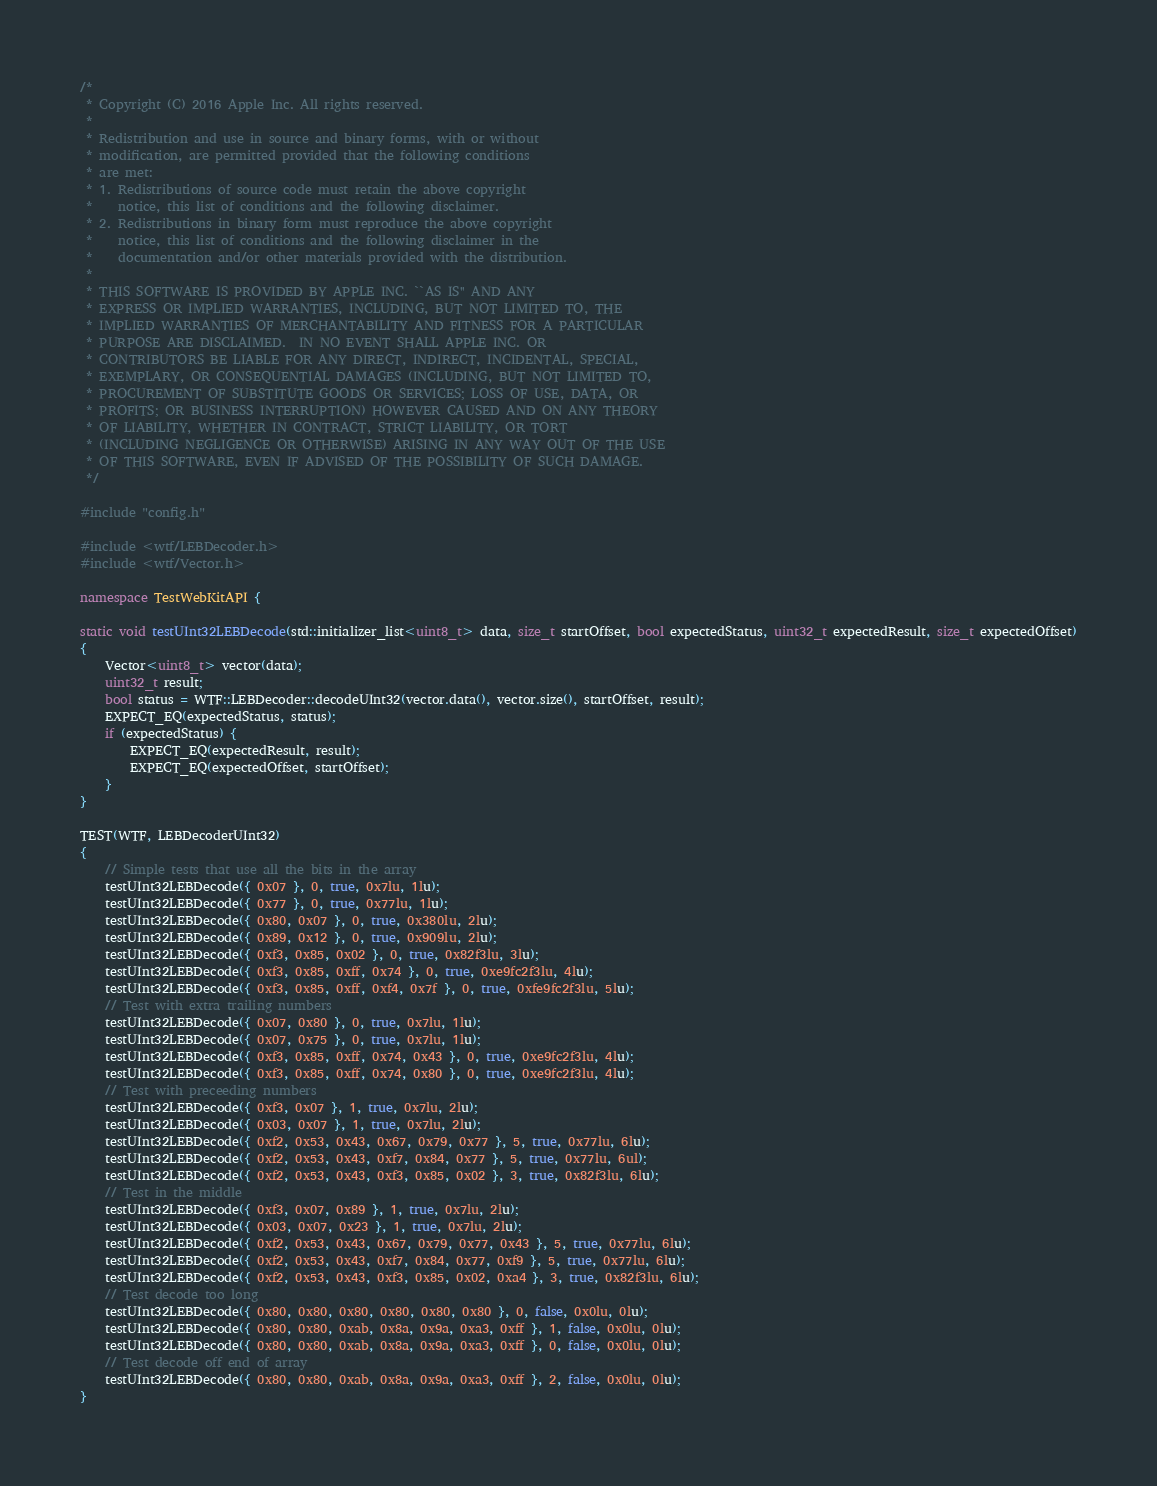Convert code to text. <code><loc_0><loc_0><loc_500><loc_500><_C++_>/*
 * Copyright (C) 2016 Apple Inc. All rights reserved.
 *
 * Redistribution and use in source and binary forms, with or without
 * modification, are permitted provided that the following conditions
 * are met:
 * 1. Redistributions of source code must retain the above copyright
 *    notice, this list of conditions and the following disclaimer.
 * 2. Redistributions in binary form must reproduce the above copyright
 *    notice, this list of conditions and the following disclaimer in the
 *    documentation and/or other materials provided with the distribution.
 *
 * THIS SOFTWARE IS PROVIDED BY APPLE INC. ``AS IS'' AND ANY
 * EXPRESS OR IMPLIED WARRANTIES, INCLUDING, BUT NOT LIMITED TO, THE
 * IMPLIED WARRANTIES OF MERCHANTABILITY AND FITNESS FOR A PARTICULAR
 * PURPOSE ARE DISCLAIMED.  IN NO EVENT SHALL APPLE INC. OR
 * CONTRIBUTORS BE LIABLE FOR ANY DIRECT, INDIRECT, INCIDENTAL, SPECIAL,
 * EXEMPLARY, OR CONSEQUENTIAL DAMAGES (INCLUDING, BUT NOT LIMITED TO,
 * PROCUREMENT OF SUBSTITUTE GOODS OR SERVICES; LOSS OF USE, DATA, OR
 * PROFITS; OR BUSINESS INTERRUPTION) HOWEVER CAUSED AND ON ANY THEORY
 * OF LIABILITY, WHETHER IN CONTRACT, STRICT LIABILITY, OR TORT
 * (INCLUDING NEGLIGENCE OR OTHERWISE) ARISING IN ANY WAY OUT OF THE USE
 * OF THIS SOFTWARE, EVEN IF ADVISED OF THE POSSIBILITY OF SUCH DAMAGE.
 */

#include "config.h"

#include <wtf/LEBDecoder.h>
#include <wtf/Vector.h>

namespace TestWebKitAPI {

static void testUInt32LEBDecode(std::initializer_list<uint8_t> data, size_t startOffset, bool expectedStatus, uint32_t expectedResult, size_t expectedOffset)
{
    Vector<uint8_t> vector(data);
    uint32_t result;
    bool status = WTF::LEBDecoder::decodeUInt32(vector.data(), vector.size(), startOffset, result);
    EXPECT_EQ(expectedStatus, status);
    if (expectedStatus) {
        EXPECT_EQ(expectedResult, result);
        EXPECT_EQ(expectedOffset, startOffset);
    }
}

TEST(WTF, LEBDecoderUInt32)
{
    // Simple tests that use all the bits in the array
    testUInt32LEBDecode({ 0x07 }, 0, true, 0x7lu, 1lu);
    testUInt32LEBDecode({ 0x77 }, 0, true, 0x77lu, 1lu);
    testUInt32LEBDecode({ 0x80, 0x07 }, 0, true, 0x380lu, 2lu);
    testUInt32LEBDecode({ 0x89, 0x12 }, 0, true, 0x909lu, 2lu);
    testUInt32LEBDecode({ 0xf3, 0x85, 0x02 }, 0, true, 0x82f3lu, 3lu);
    testUInt32LEBDecode({ 0xf3, 0x85, 0xff, 0x74 }, 0, true, 0xe9fc2f3lu, 4lu);
    testUInt32LEBDecode({ 0xf3, 0x85, 0xff, 0xf4, 0x7f }, 0, true, 0xfe9fc2f3lu, 5lu);
    // Test with extra trailing numbers
    testUInt32LEBDecode({ 0x07, 0x80 }, 0, true, 0x7lu, 1lu);
    testUInt32LEBDecode({ 0x07, 0x75 }, 0, true, 0x7lu, 1lu);
    testUInt32LEBDecode({ 0xf3, 0x85, 0xff, 0x74, 0x43 }, 0, true, 0xe9fc2f3lu, 4lu);
    testUInt32LEBDecode({ 0xf3, 0x85, 0xff, 0x74, 0x80 }, 0, true, 0xe9fc2f3lu, 4lu);
    // Test with preceeding numbers
    testUInt32LEBDecode({ 0xf3, 0x07 }, 1, true, 0x7lu, 2lu);
    testUInt32LEBDecode({ 0x03, 0x07 }, 1, true, 0x7lu, 2lu);
    testUInt32LEBDecode({ 0xf2, 0x53, 0x43, 0x67, 0x79, 0x77 }, 5, true, 0x77lu, 6lu);
    testUInt32LEBDecode({ 0xf2, 0x53, 0x43, 0xf7, 0x84, 0x77 }, 5, true, 0x77lu, 6ul);
    testUInt32LEBDecode({ 0xf2, 0x53, 0x43, 0xf3, 0x85, 0x02 }, 3, true, 0x82f3lu, 6lu);
    // Test in the middle
    testUInt32LEBDecode({ 0xf3, 0x07, 0x89 }, 1, true, 0x7lu, 2lu);
    testUInt32LEBDecode({ 0x03, 0x07, 0x23 }, 1, true, 0x7lu, 2lu);
    testUInt32LEBDecode({ 0xf2, 0x53, 0x43, 0x67, 0x79, 0x77, 0x43 }, 5, true, 0x77lu, 6lu);
    testUInt32LEBDecode({ 0xf2, 0x53, 0x43, 0xf7, 0x84, 0x77, 0xf9 }, 5, true, 0x77lu, 6lu);
    testUInt32LEBDecode({ 0xf2, 0x53, 0x43, 0xf3, 0x85, 0x02, 0xa4 }, 3, true, 0x82f3lu, 6lu);
    // Test decode too long
    testUInt32LEBDecode({ 0x80, 0x80, 0x80, 0x80, 0x80, 0x80 }, 0, false, 0x0lu, 0lu);
    testUInt32LEBDecode({ 0x80, 0x80, 0xab, 0x8a, 0x9a, 0xa3, 0xff }, 1, false, 0x0lu, 0lu);
    testUInt32LEBDecode({ 0x80, 0x80, 0xab, 0x8a, 0x9a, 0xa3, 0xff }, 0, false, 0x0lu, 0lu);
    // Test decode off end of array
    testUInt32LEBDecode({ 0x80, 0x80, 0xab, 0x8a, 0x9a, 0xa3, 0xff }, 2, false, 0x0lu, 0lu);
}
</code> 